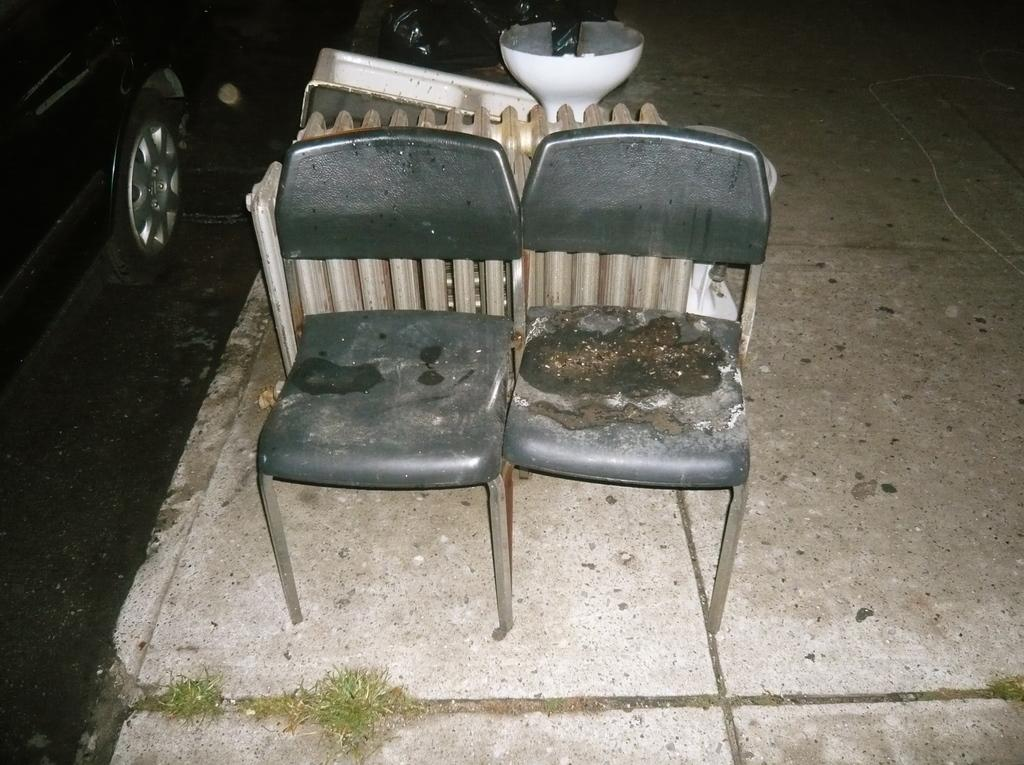What type of furniture can be seen in the image? There are empty chairs in the image. What material is the fence made of in the image? The fence in the image is made of wood. What color are the objects in the image? There are objects that are white in color in the image. What type of vehicles are present in the image? There are vehicles in the image. What type of ground surface is visible in the image? There is grass on the ground in the image. What is the distribution of beliefs among the chairs in the image? There are no beliefs associated with the chairs in the image, as they are empty and inanimate objects. What type of property is the wooden fence protecting in the image? There is no indication of any property being protected by the wooden fence in the image. 